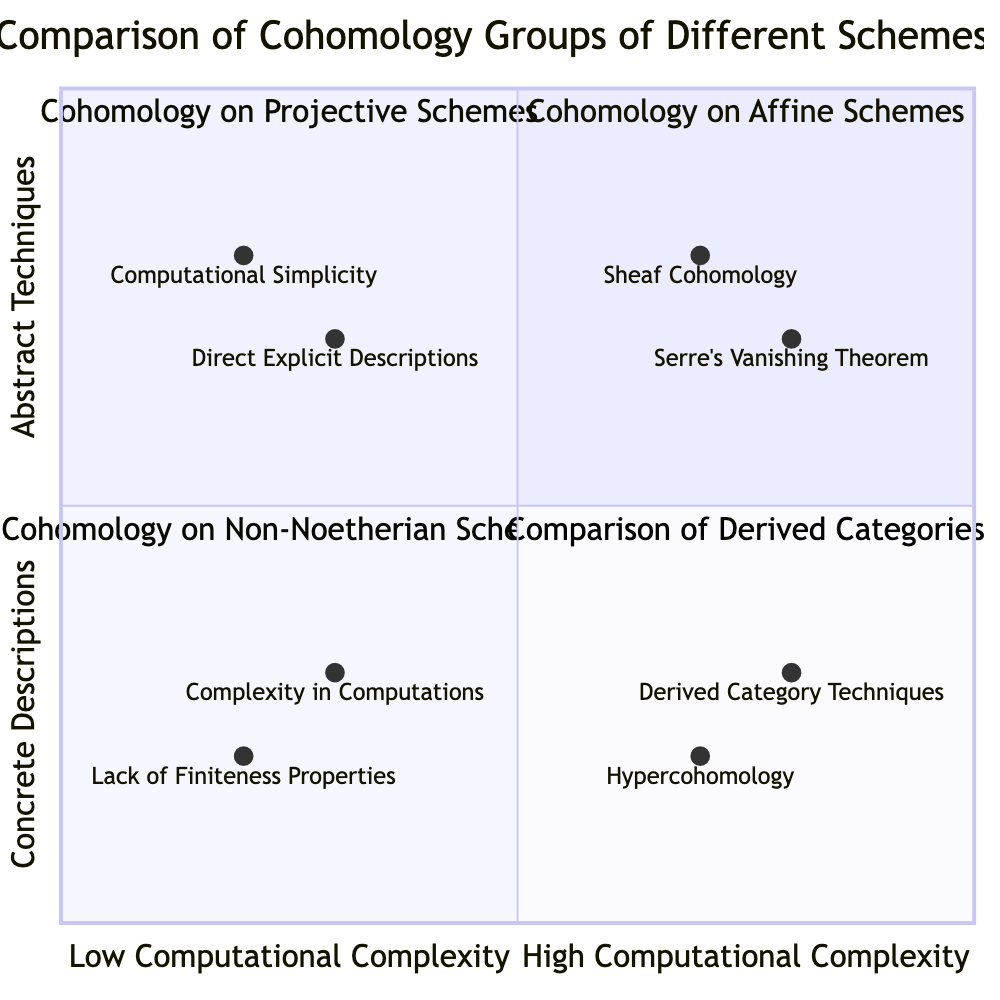What are the two elements in the top left quadrant? The top left quadrant is titled "Cohomology on Affine Schemes" and contains the elements "Computational Simplicity" and "Direct Explicit Descriptions."
Answer: Computational Simplicity, Direct Explicit Descriptions Which quadrant discusses the Sheaf Cohomology? The top right quadrant is titled "Cohomology on Projective Schemes," which includes the element "Sheaf Cohomology."
Answer: Cohomology on Projective Schemes How many elements are in the bottom left quadrant? The bottom left quadrant titled "Cohomology on Non-Noetherian Schemes" contains two elements: "Complexity in Computations" and "Lack of Finiteness Properties."
Answer: Two Which element appears in the bottom right quadrant? The bottom right quadrant is titled "Comparison of Derived Categories" and contains two elements: "Derived Category Techniques" and "Hypercohomology."
Answer: Derived Category Techniques, Hypercohomology What is the relationship between Computational Simplicity and Complexity in Computations? "Computational Simplicity" is located in the top left quadrant (low complexity) while "Complexity in Computations" is in the bottom left quadrant (medium complexity), indicating a contrast in computational ease.
Answer: Contrast How many quadrants focus on comparative techniques? There are two quadrants focusing on comparative techniques: "Cohomology on Projective Schemes" and "Comparison of Derived Categories."
Answer: Two Which quadrant includes Serre's Vanishing Theorem? The top right quadrant titled "Cohomology on Projective Schemes" includes the element "Serre's Vanishing Theorem."
Answer: Cohomology on Projective Schemes In which quadrant would you find "Hypercohomology"? "Hypercohomology" can be found in the bottom right quadrant, which is titled "Comparison of Derived Categories."
Answer: Comparison of Derived Categories 